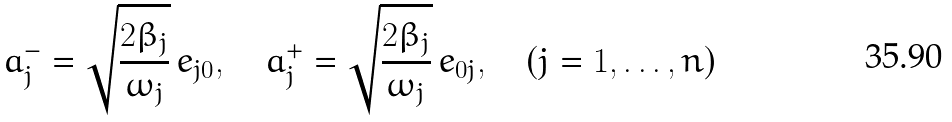<formula> <loc_0><loc_0><loc_500><loc_500>a _ { j } ^ { - } = \sqrt { \frac { 2 \beta _ { j } } { \omega _ { j } } } \, e _ { j 0 } , \quad a _ { j } ^ { + } = \sqrt { \frac { 2 \beta _ { j } } { \omega _ { j } } } \, e _ { 0 j } , \quad ( j = 1 , \dots , n )</formula> 